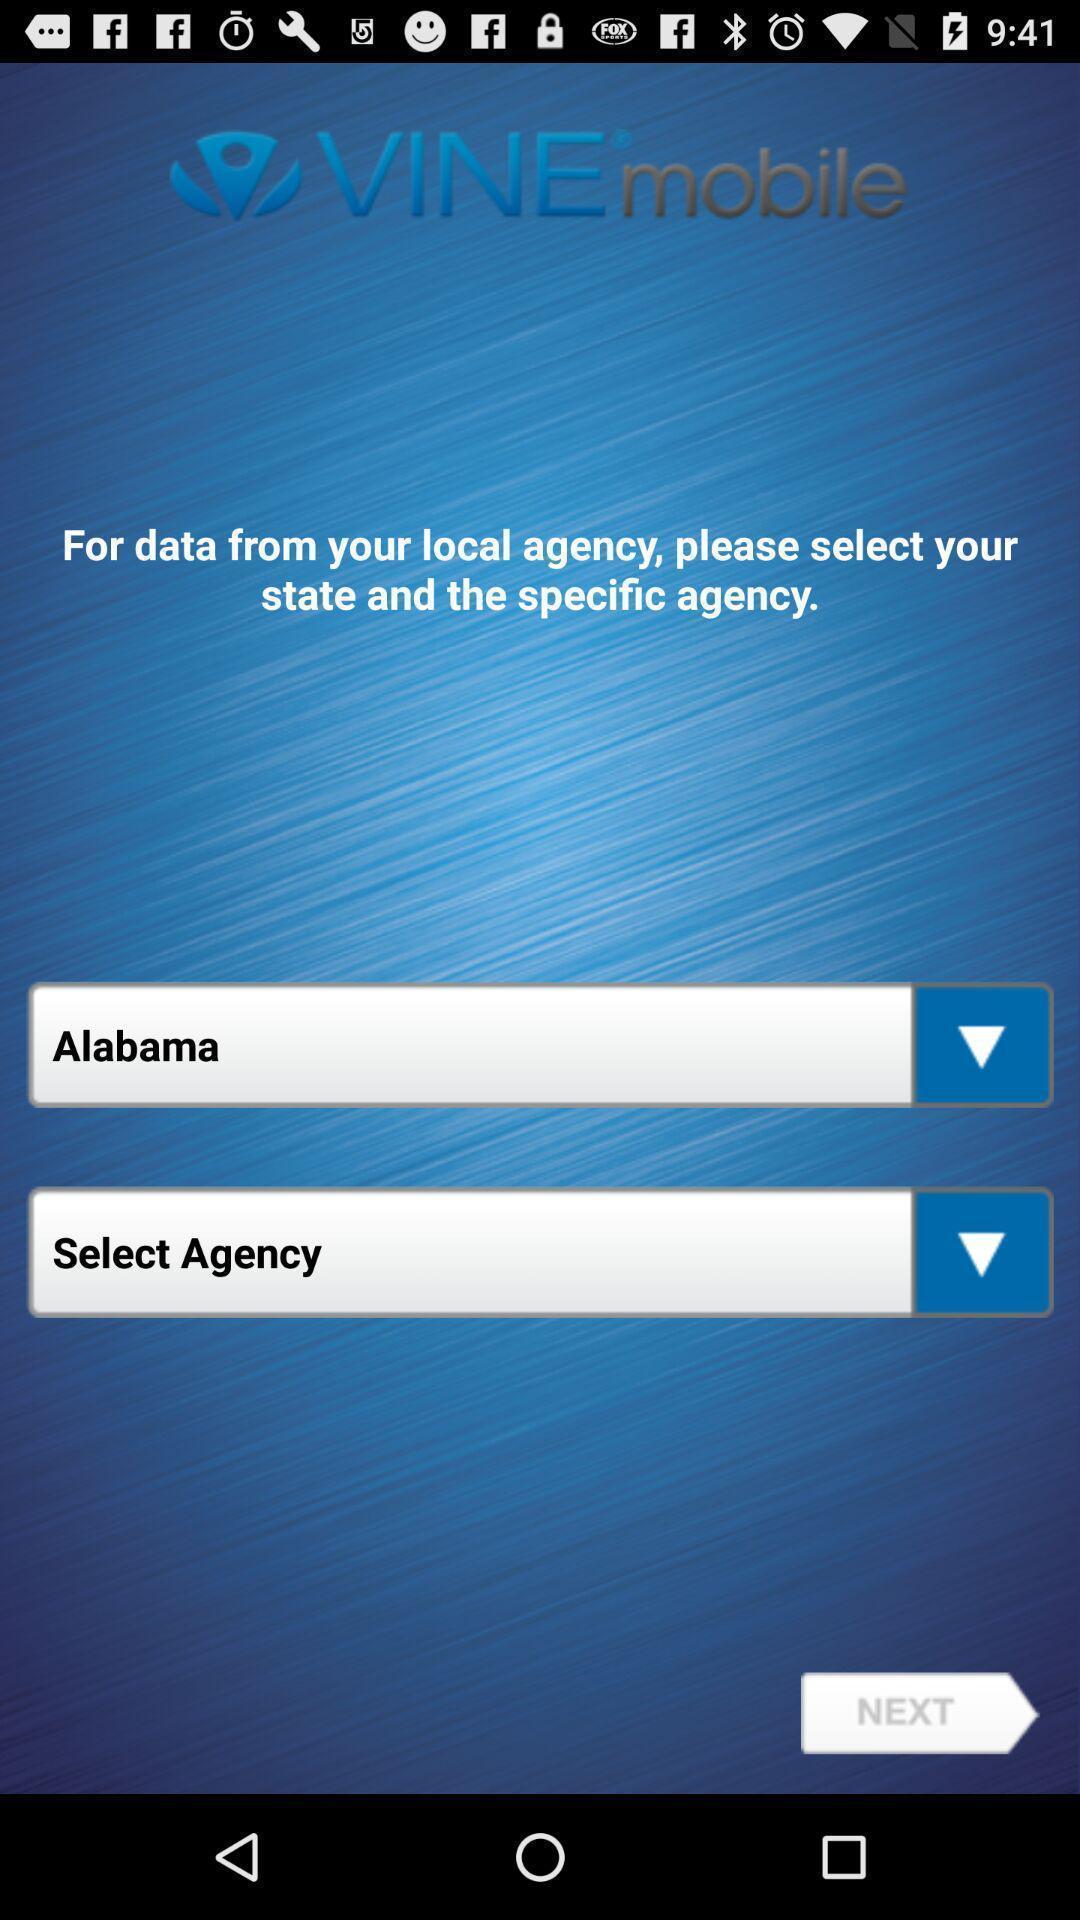Tell me about the visual elements in this screen capture. Page showing sign in options. 